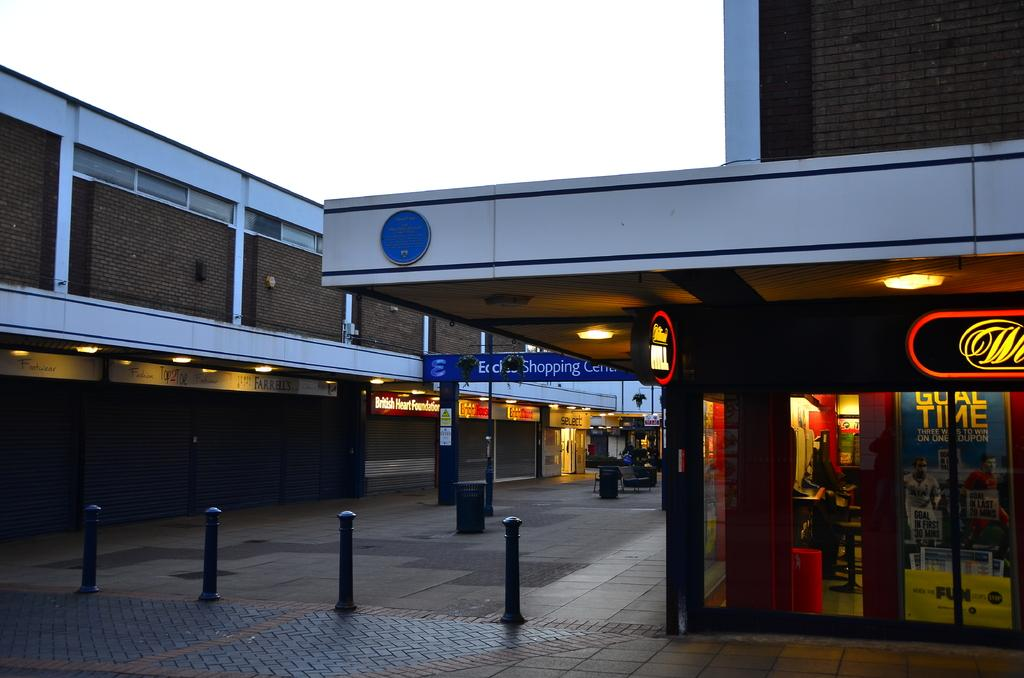Provide a one-sentence caption for the provided image. One of the businesses in this center is the British Heart Foundation. 